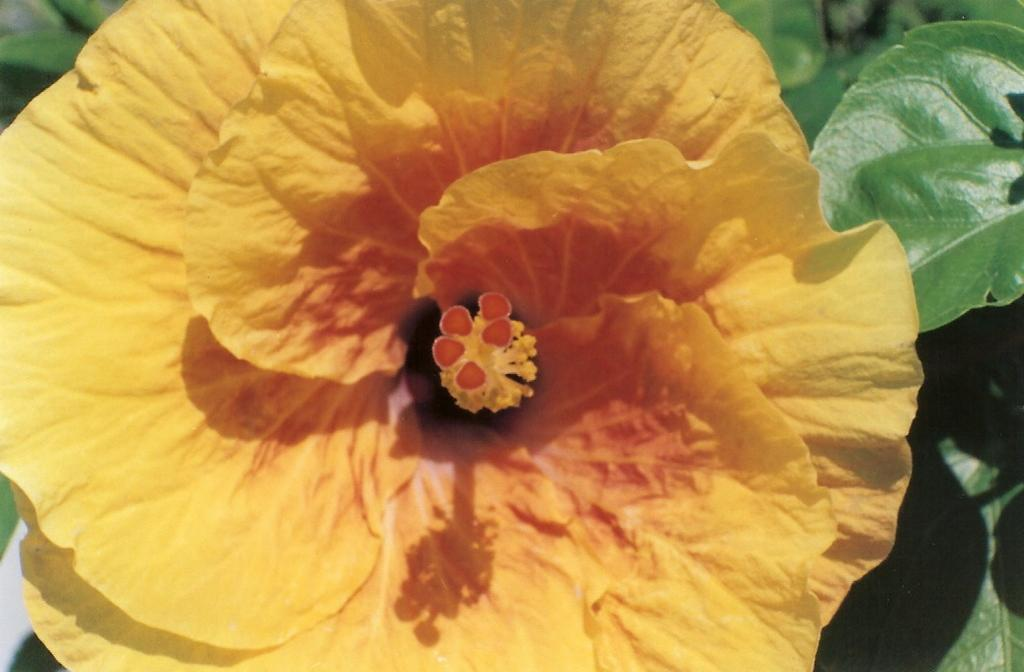What type of plant can be seen in the image? There is a flower in the image. What parts of the plant are visible in the image? There are leaves and petals of the flower in the image. What type of brass instrument is being played in the image? There is no brass instrument present in the image; it features a flower with leaves and petals. 